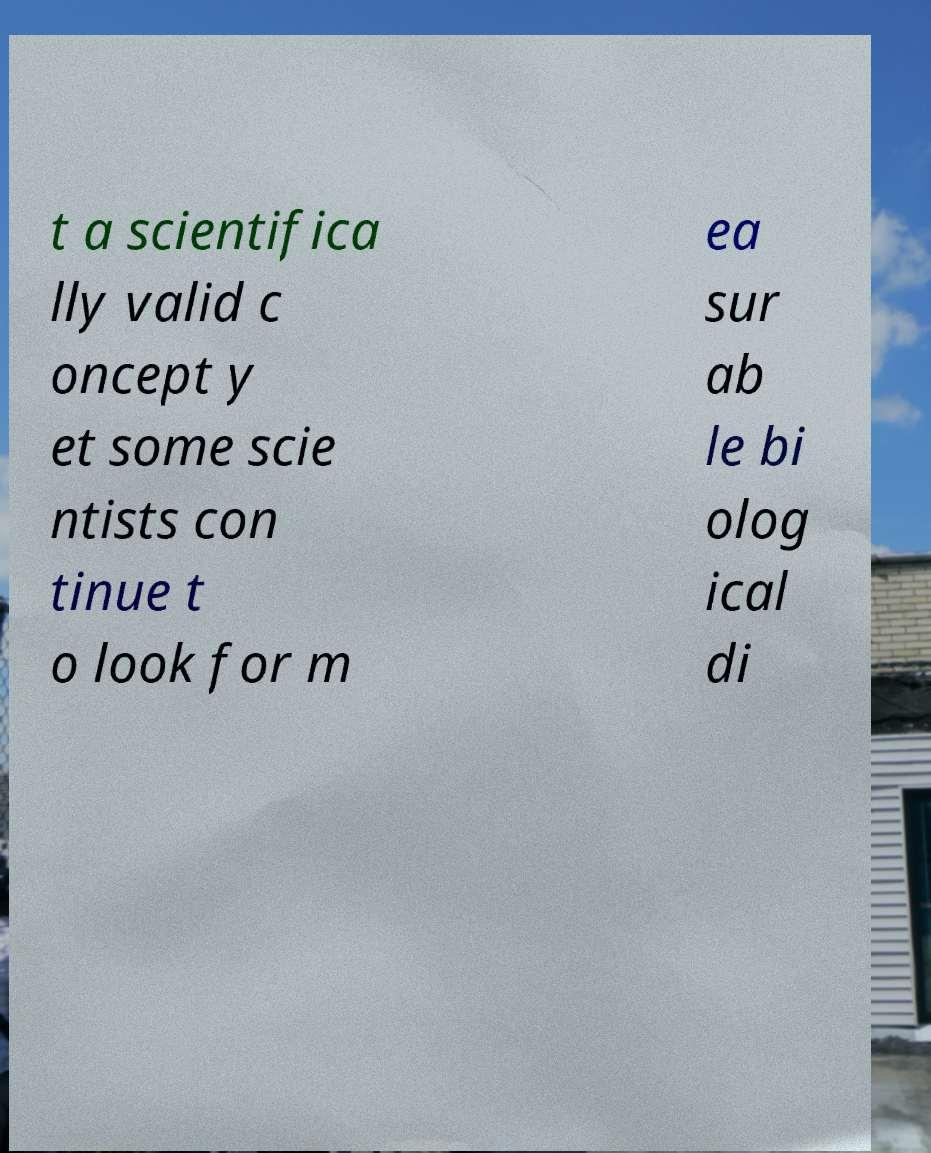Please identify and transcribe the text found in this image. t a scientifica lly valid c oncept y et some scie ntists con tinue t o look for m ea sur ab le bi olog ical di 